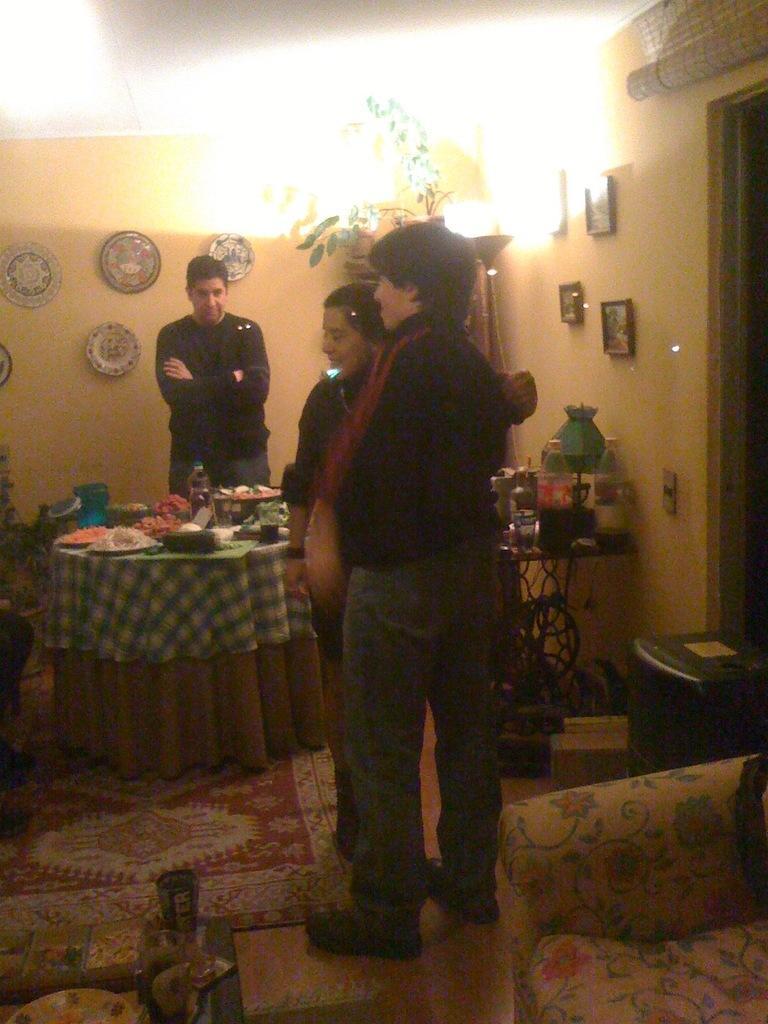Describe this image in one or two sentences. 3 people are standing at here and there right there is a light. 